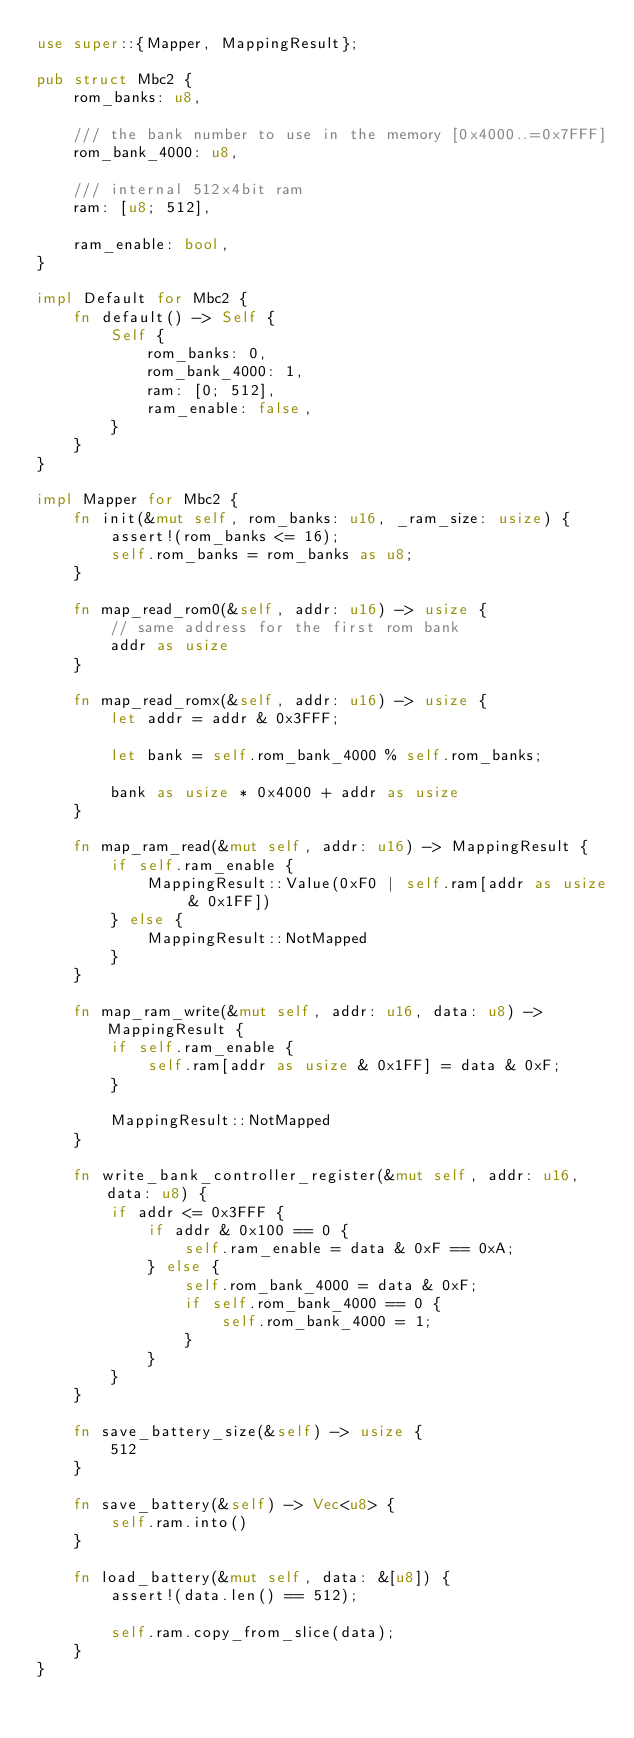<code> <loc_0><loc_0><loc_500><loc_500><_Rust_>use super::{Mapper, MappingResult};

pub struct Mbc2 {
    rom_banks: u8,

    /// the bank number to use in the memory [0x4000..=0x7FFF]
    rom_bank_4000: u8,

    /// internal 512x4bit ram
    ram: [u8; 512],

    ram_enable: bool,
}

impl Default for Mbc2 {
    fn default() -> Self {
        Self {
            rom_banks: 0,
            rom_bank_4000: 1,
            ram: [0; 512],
            ram_enable: false,
        }
    }
}

impl Mapper for Mbc2 {
    fn init(&mut self, rom_banks: u16, _ram_size: usize) {
        assert!(rom_banks <= 16);
        self.rom_banks = rom_banks as u8;
    }

    fn map_read_rom0(&self, addr: u16) -> usize {
        // same address for the first rom bank
        addr as usize
    }

    fn map_read_romx(&self, addr: u16) -> usize {
        let addr = addr & 0x3FFF;

        let bank = self.rom_bank_4000 % self.rom_banks;

        bank as usize * 0x4000 + addr as usize
    }

    fn map_ram_read(&mut self, addr: u16) -> MappingResult {
        if self.ram_enable {
            MappingResult::Value(0xF0 | self.ram[addr as usize & 0x1FF])
        } else {
            MappingResult::NotMapped
        }
    }

    fn map_ram_write(&mut self, addr: u16, data: u8) -> MappingResult {
        if self.ram_enable {
            self.ram[addr as usize & 0x1FF] = data & 0xF;
        }

        MappingResult::NotMapped
    }

    fn write_bank_controller_register(&mut self, addr: u16, data: u8) {
        if addr <= 0x3FFF {
            if addr & 0x100 == 0 {
                self.ram_enable = data & 0xF == 0xA;
            } else {
                self.rom_bank_4000 = data & 0xF;
                if self.rom_bank_4000 == 0 {
                    self.rom_bank_4000 = 1;
                }
            }
        }
    }

    fn save_battery_size(&self) -> usize {
        512
    }

    fn save_battery(&self) -> Vec<u8> {
        self.ram.into()
    }

    fn load_battery(&mut self, data: &[u8]) {
        assert!(data.len() == 512);

        self.ram.copy_from_slice(data);
    }
}
</code> 